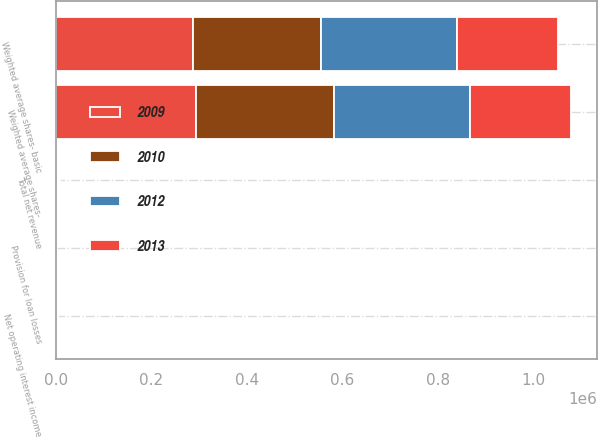<chart> <loc_0><loc_0><loc_500><loc_500><stacked_bar_chart><ecel><fcel>Net operating interest income<fcel>Total net revenue<fcel>Provision for loan losses<fcel>Weighted average shares- basic<fcel>Weighted average shares-<nl><fcel>2009<fcel>981.8<fcel>1723.7<fcel>143.5<fcel>286991<fcel>292589<nl><fcel>2012<fcel>1085.1<fcel>1899.5<fcel>354.6<fcel>285748<fcel>285748<nl><fcel>2010<fcel>1220<fcel>2036.6<fcel>440.6<fcel>267291<fcel>289822<nl><fcel>2013<fcel>1226.3<fcel>2077.9<fcel>779.4<fcel>211302<fcel>211302<nl></chart> 